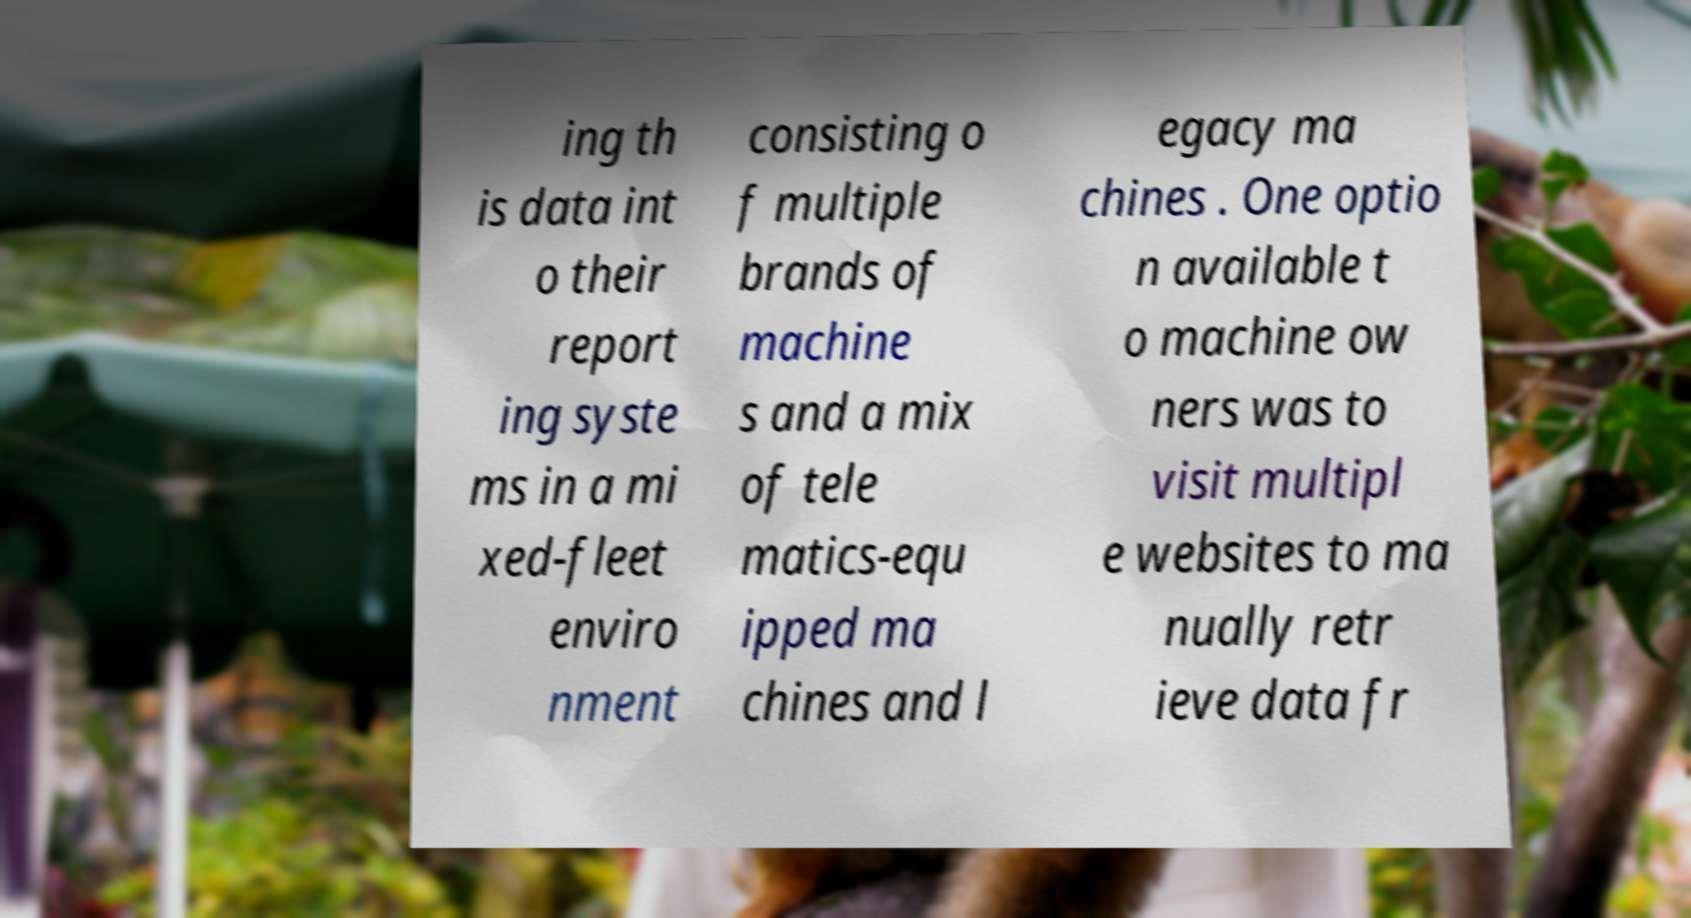For documentation purposes, I need the text within this image transcribed. Could you provide that? ing th is data int o their report ing syste ms in a mi xed-fleet enviro nment consisting o f multiple brands of machine s and a mix of tele matics-equ ipped ma chines and l egacy ma chines . One optio n available t o machine ow ners was to visit multipl e websites to ma nually retr ieve data fr 